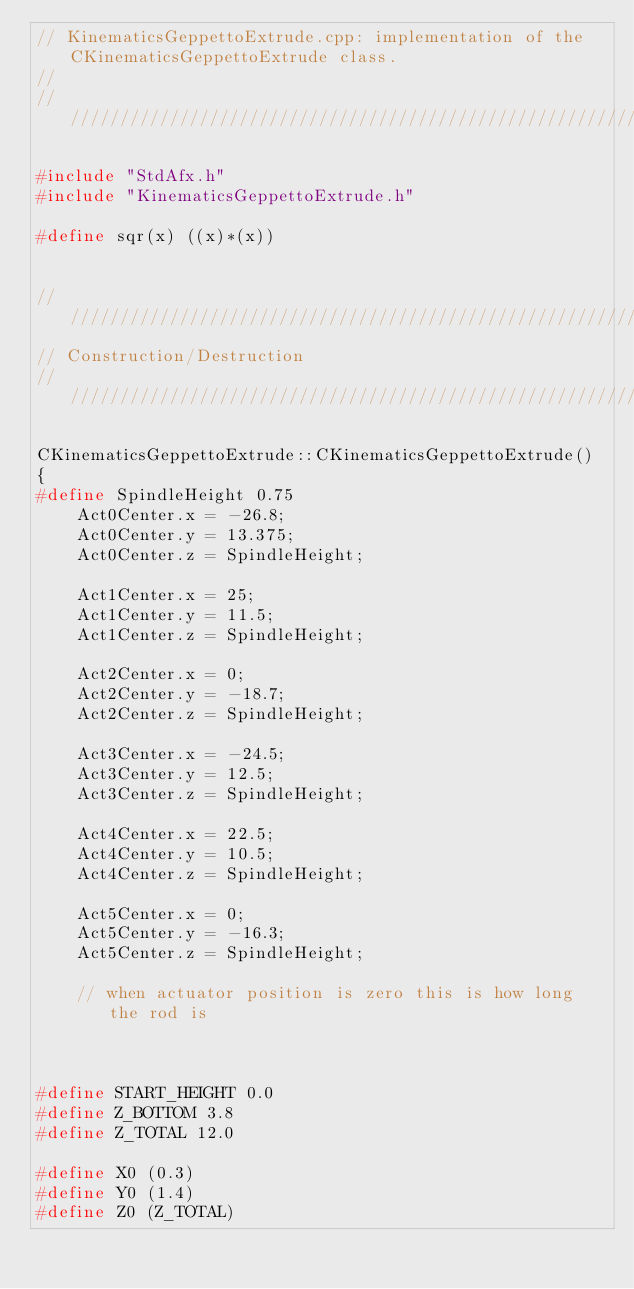<code> <loc_0><loc_0><loc_500><loc_500><_C++_>// KinematicsGeppettoExtrude.cpp: implementation of the CKinematicsGeppettoExtrude class.
//
//////////////////////////////////////////////////////////////////////

#include "StdAfx.h"
#include "KinematicsGeppettoExtrude.h"

#define sqr(x) ((x)*(x))


//////////////////////////////////////////////////////////////////////
// Construction/Destruction
//////////////////////////////////////////////////////////////////////

CKinematicsGeppettoExtrude::CKinematicsGeppettoExtrude()
{
#define SpindleHeight 0.75
	Act0Center.x = -26.8;
	Act0Center.y = 13.375;
	Act0Center.z = SpindleHeight;

	Act1Center.x = 25;
	Act1Center.y = 11.5;
	Act1Center.z = SpindleHeight;

	Act2Center.x = 0;
	Act2Center.y = -18.7;
	Act2Center.z = SpindleHeight;

	Act3Center.x = -24.5;
	Act3Center.y = 12.5;
	Act3Center.z = SpindleHeight;

	Act4Center.x = 22.5;
	Act4Center.y = 10.5;
	Act4Center.z = SpindleHeight;

	Act5Center.x = 0;
	Act5Center.y = -16.3;
	Act5Center.z = SpindleHeight;

	// when actuator position is zero this is how long the rod is



#define START_HEIGHT 0.0
#define Z_BOTTOM 3.8
#define Z_TOTAL 12.0

#define X0 (0.3)
#define Y0 (1.4)
#define Z0 (Z_TOTAL)
</code> 